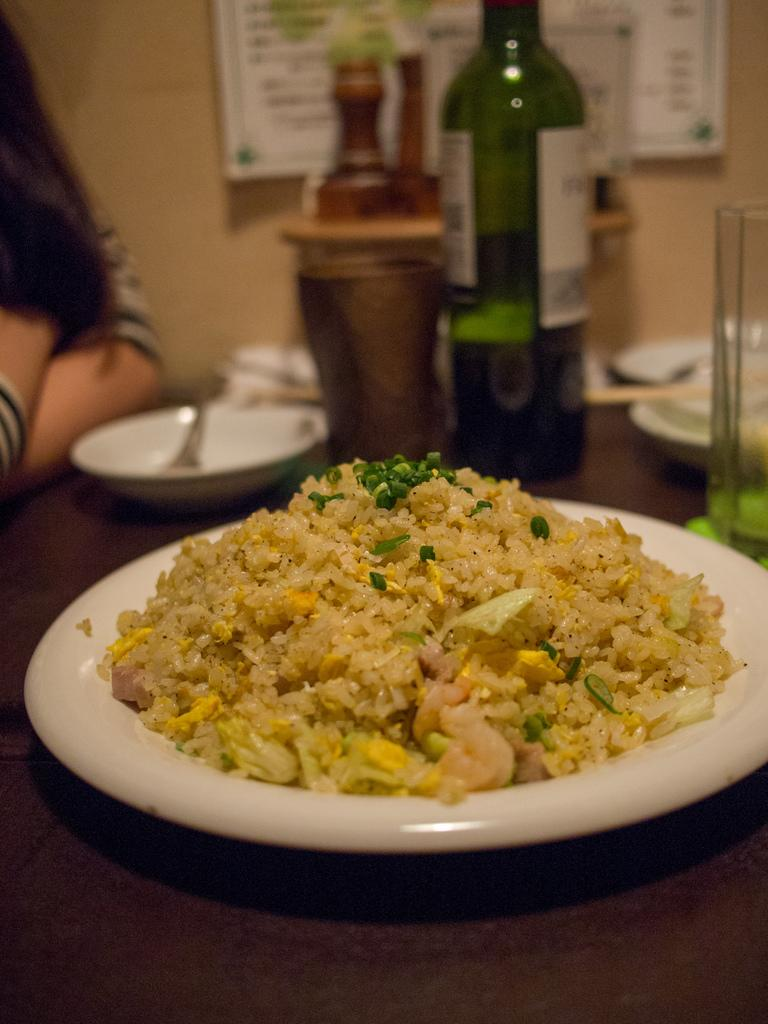What is the main piece of furniture in the image? There is a table in the image. What is on the table? There is food, a plate, a bowl, a bottle, and a glass on the table. Can you describe the person in the image? There is a person in the image, but their appearance or actions are not specified. What type of background can be seen in the image? There is a wall and a board in the image. Can you tell me how deep the river is in the image? There is no river present in the image; it features a table with various items on it, a person, and a background with a wall and a board. 